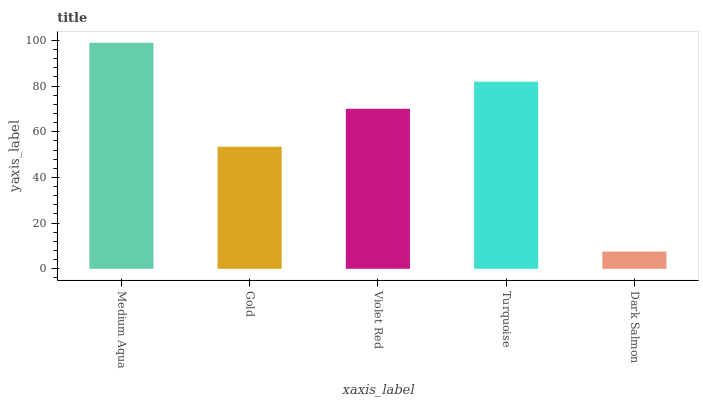Is Gold the minimum?
Answer yes or no. No. Is Gold the maximum?
Answer yes or no. No. Is Medium Aqua greater than Gold?
Answer yes or no. Yes. Is Gold less than Medium Aqua?
Answer yes or no. Yes. Is Gold greater than Medium Aqua?
Answer yes or no. No. Is Medium Aqua less than Gold?
Answer yes or no. No. Is Violet Red the high median?
Answer yes or no. Yes. Is Violet Red the low median?
Answer yes or no. Yes. Is Dark Salmon the high median?
Answer yes or no. No. Is Turquoise the low median?
Answer yes or no. No. 